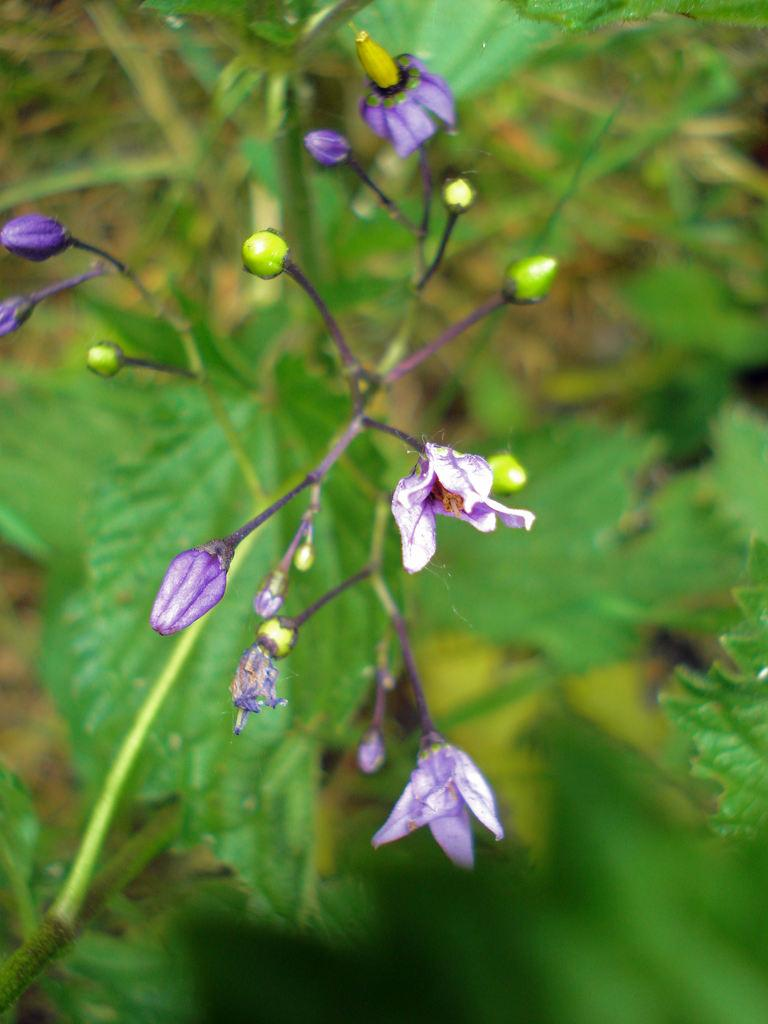What type of living organism is present in the image? There is a plant in the image. What is the plant's reproductive structure? The plant has a flower. Are there any unopened flowers on the plant? Yes, the plant has buds. How many bricks are used to support the plant in the image? There are no bricks present in the image; the plant is not supported by any bricks. 